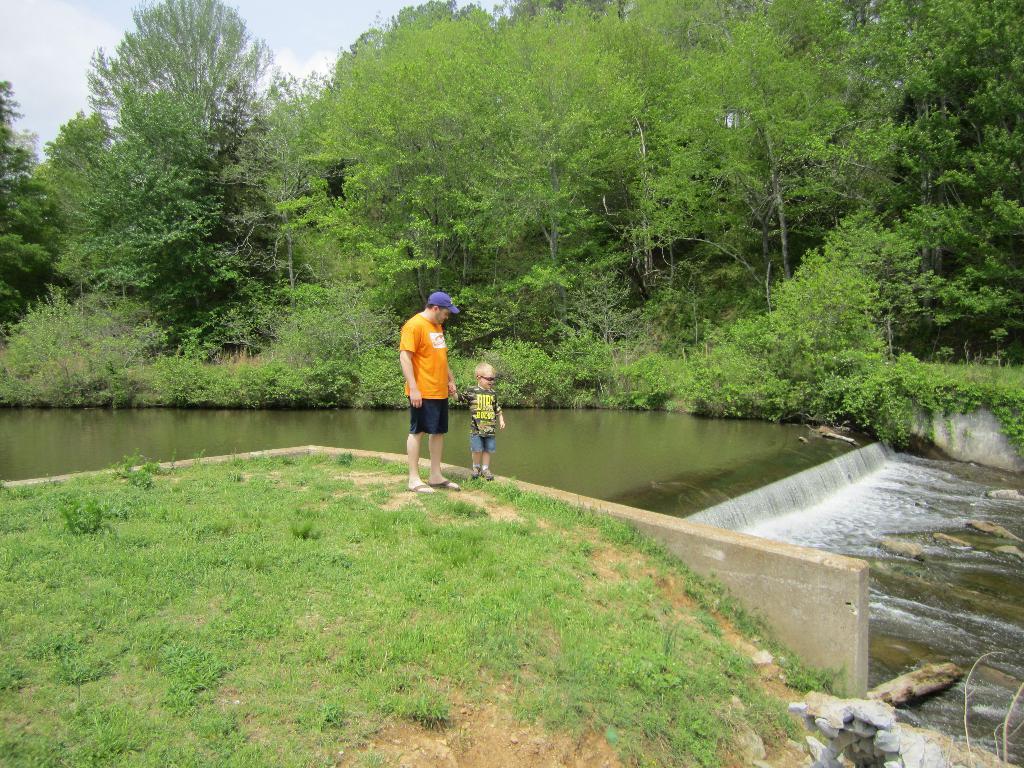Could you give a brief overview of what you see in this image? This is an outside view. At the bottom, I can see the grass. Here a man and a boy are standing. On the right side there is river. In the background there are many trees. At the top of the image I can see the sky. 